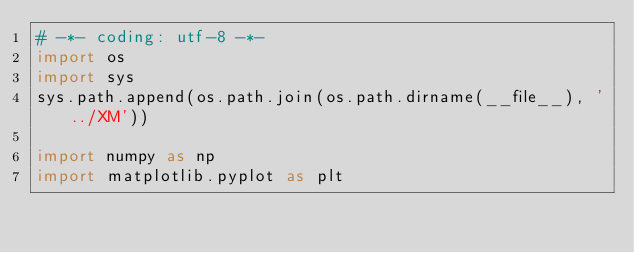<code> <loc_0><loc_0><loc_500><loc_500><_Python_># -*- coding: utf-8 -*-
import os
import sys
sys.path.append(os.path.join(os.path.dirname(__file__), '../XM'))

import numpy as np
import matplotlib.pyplot as plt</code> 